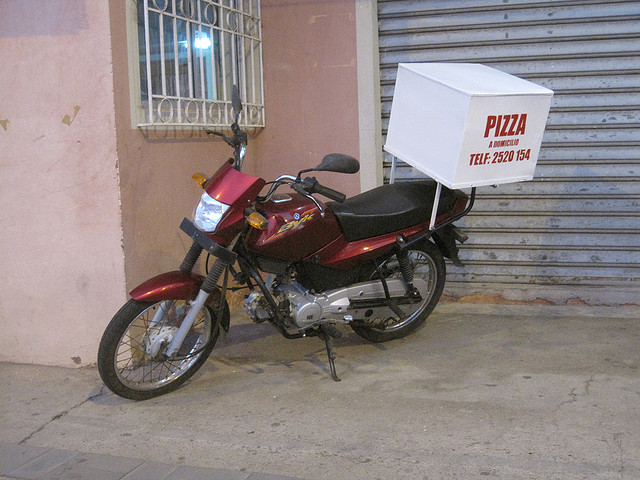Identify the text contained in this image. PIZZA A TEIF: 2520 154 